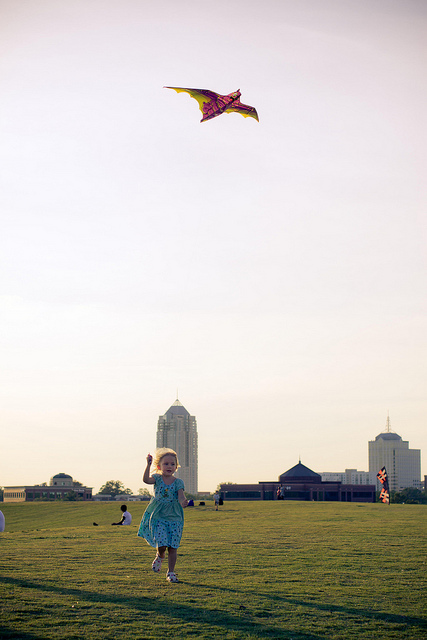<image>What game is being played on the ground? It is unclear what game is being played on the ground. The answers suggest it could be kite flying or there could be no game being played at all. What game is being played on the ground? It is ambiguous what game is being played on the ground. It can be either kite flying or frisbee. 